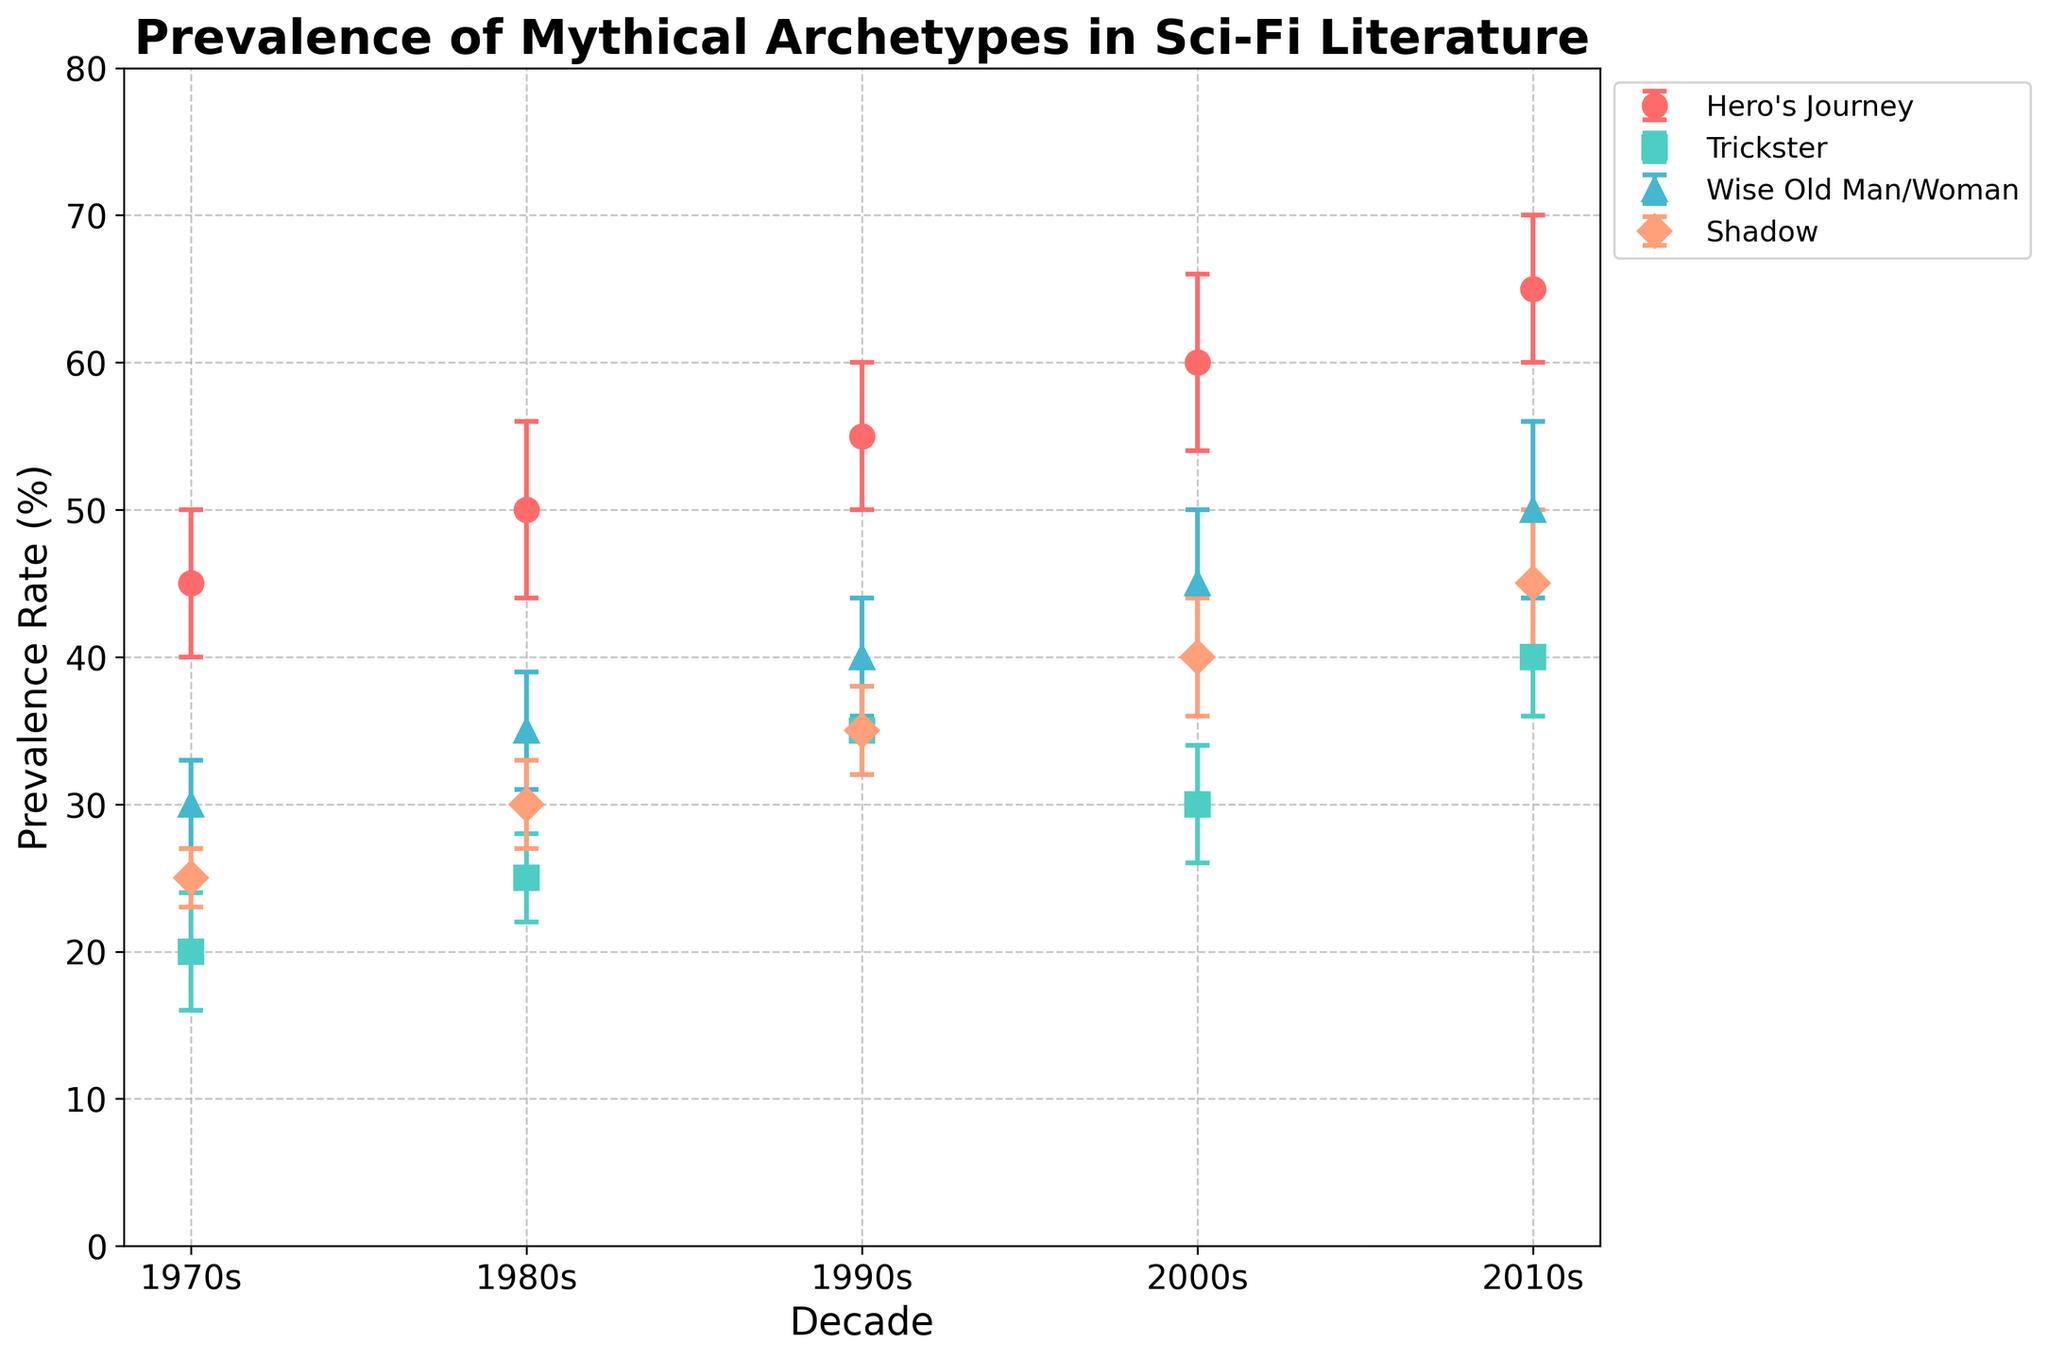What's the title of the plot? The title is displayed at the top of the plot, which reads "Prevalence of Mythical Archetypes in Sci-Fi Literature".
Answer: Prevalence of Mythical Archetypes in Sci-Fi Literature Which archetype has the highest prevalence rate in the 2010s? Looking at the data points for the 2010s, the "Hero's Journey" archetype has the highest prevalence rate at 65%.
Answer: Hero's Journey What is the difference in prevalence rate of the "Trickster" archetype between the 1980s and the 2010s? The prevalence rate of "Trickster" archetype in the 1980s is 25%, and in the 2010s it is 40%. The difference is 40% - 25% = 15%.
Answer: 15% How many mythical archetypes are compared in the figure? There are four different archetypes represented by different markers and colors in the legend.
Answer: 4 Which decade shows the sharpest increase in the prevalence rate of the "Hero's Journey" archetype? From the 1970s to the 2010s, the sharpest increase in "Hero's Journey" prevalence rate happens between the 2000s (60%) and 2010s (65%), an increase of 5%.
Answer: 2000s to 2010s For the "Wise Old Man/Woman" archetype, what is the average prevalence rate from the 1970s to the 2010s? The prevalence rates are 30%, 35%, 40%, 45%, and 50%. Adding them gives 30 + 35 + 40 + 45 + 50 = 200, and dividing by 5 gives 200 / 5 = 40%.
Answer: 40% Which two archetypes have the smallest error margins in the 1970s, and what is the difference between their prevalence rates? The archetypes "Shadow" and "Wise Old Man/Woman" have the smallest error margins (2% and 3%, respectively). Their prevalence rates are 25% (Shadow) and 30% (Wise Old Man/Woman). The difference is 30% - 25% = 5%.
Answer: Shadow and Wise Old Man/Woman, 5% Compare the prevalence rate of "Hero's Journey" in the 1980s with the "Wise Old Man/Woman" in the 2010s. Which is higher and by how much? "Hero's Journey" in the 1980s is 50%, and "Wise Old Man/Woman" in the 2010s is 50%. They are equal, so the difference is 0%.
Answer: They are equal, 0% What is the combined prevalence rate for all archetypes in the 1990s? Summing the prevalence rates for all archetypes in the 1990s gives 55 + 35 + 40 + 35 = 165%.
Answer: 165% Which archetype has the lowest prevalence rate in the 1970s, and what is its value? The "Trickster" archetype has the lowest prevalence rate in the 1970s at 20%.
Answer: Trickster, 20% 